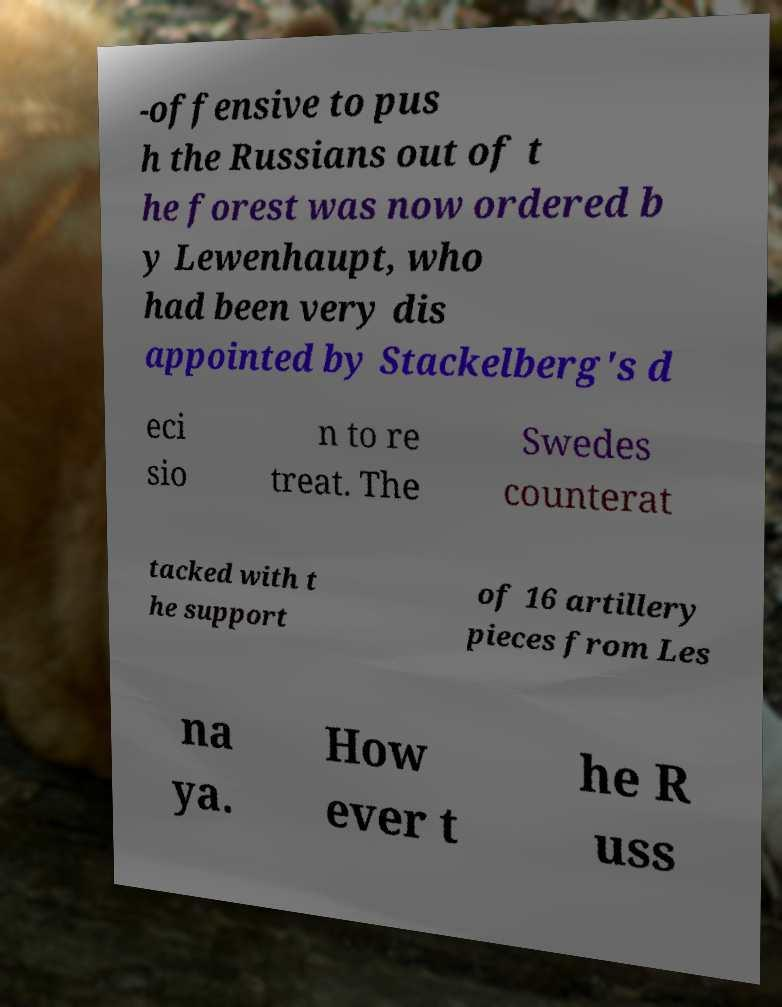Could you extract and type out the text from this image? -offensive to pus h the Russians out of t he forest was now ordered b y Lewenhaupt, who had been very dis appointed by Stackelberg's d eci sio n to re treat. The Swedes counterat tacked with t he support of 16 artillery pieces from Les na ya. How ever t he R uss 